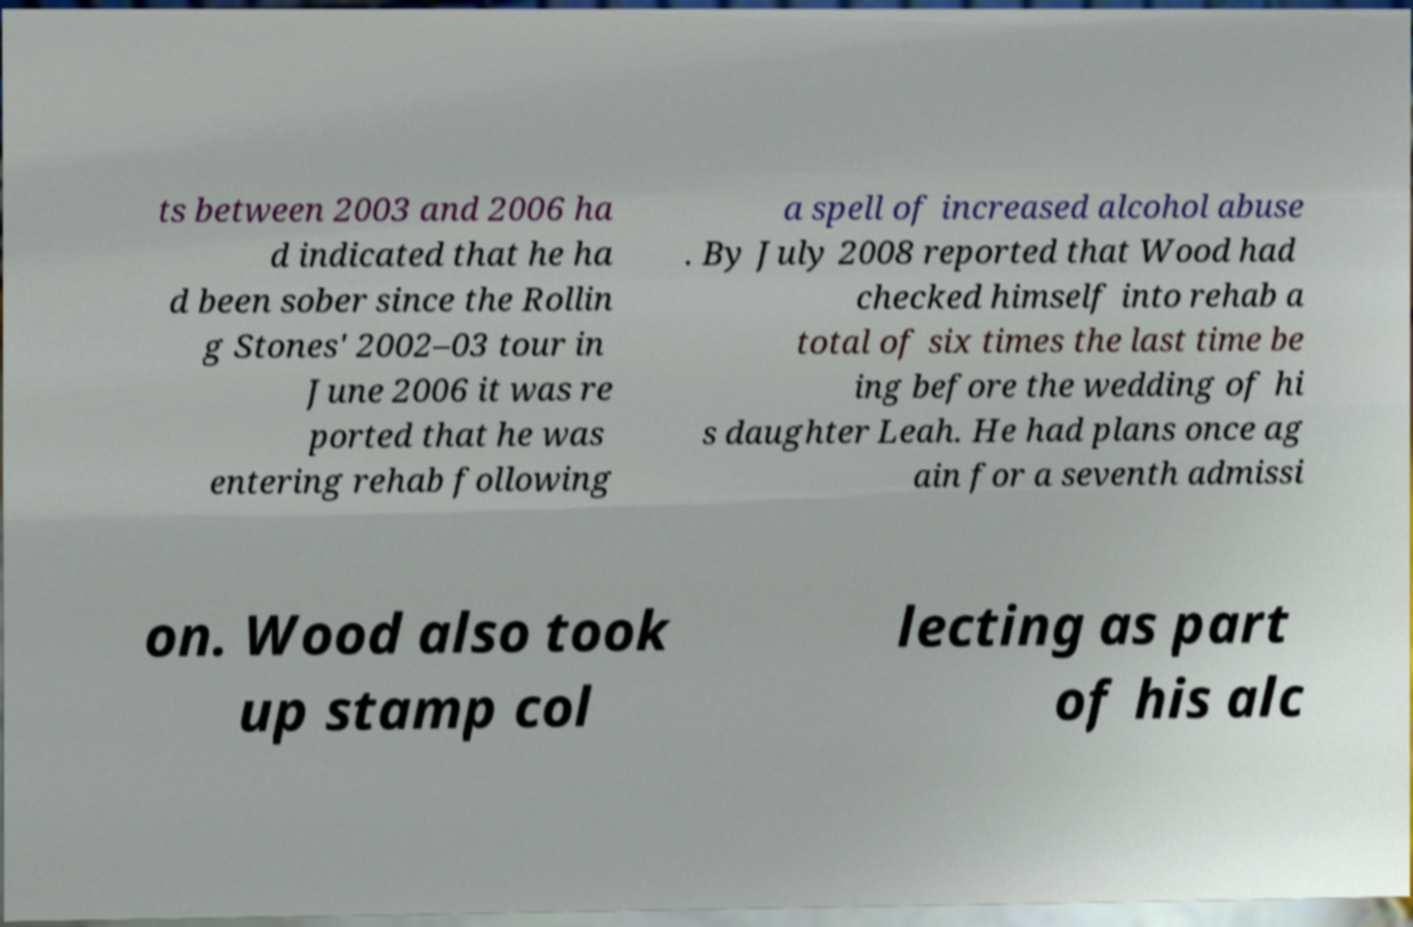Could you extract and type out the text from this image? ts between 2003 and 2006 ha d indicated that he ha d been sober since the Rollin g Stones' 2002–03 tour in June 2006 it was re ported that he was entering rehab following a spell of increased alcohol abuse . By July 2008 reported that Wood had checked himself into rehab a total of six times the last time be ing before the wedding of hi s daughter Leah. He had plans once ag ain for a seventh admissi on. Wood also took up stamp col lecting as part of his alc 